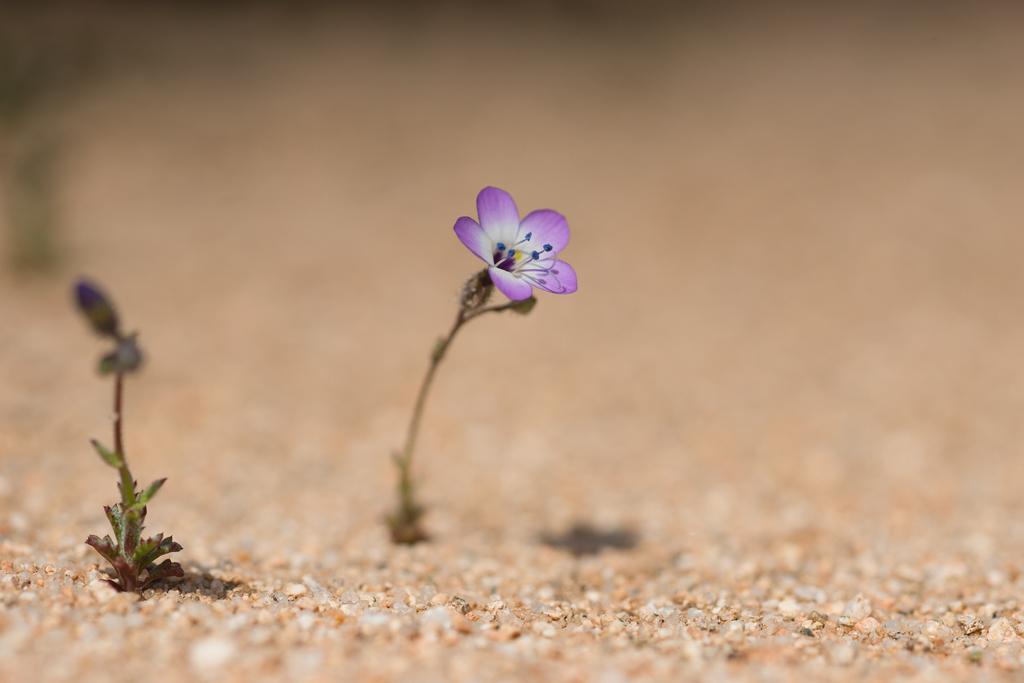Can you describe this image briefly? In the middle of the picture, we see a violet color flower with five petals. At the bottom of the picture, we see small stones and in the background, it is blurred. 